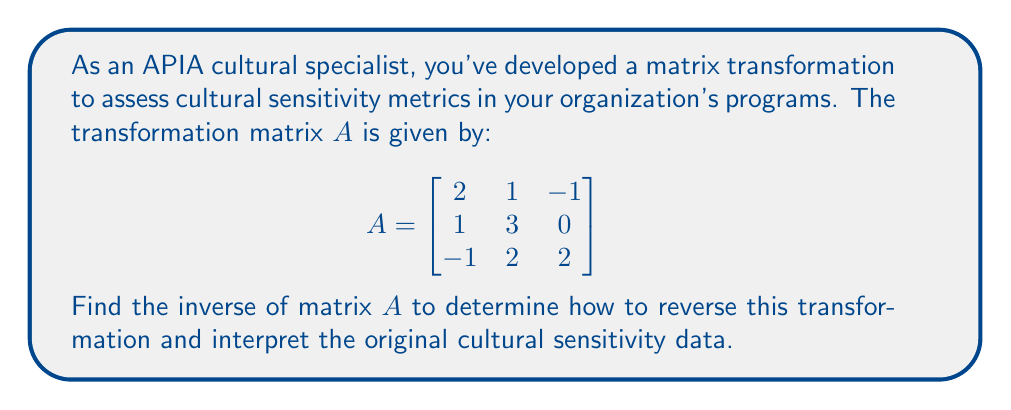Show me your answer to this math problem. To find the inverse of matrix $A$, we'll follow these steps:

1) First, calculate the determinant of $A$ to ensure it's invertible:
   $$\det(A) = 2(3\cdot2 - 0\cdot2) - 1(1\cdot2 - (-1)\cdot2) + (-1)(1\cdot0 - 3\cdot(-1)) = 12 - 6 + 3 = 9$$
   Since $\det(A) \neq 0$, $A$ is invertible.

2) Find the matrix of cofactors:
   $$\text{cof}(A) = \begin{bmatrix}
   (3\cdot2 - 0\cdot2) & -(1\cdot2 - (-1)\cdot2) & (1\cdot0 - 3\cdot(-1)) \\
   -(2\cdot2 - (-1)\cdot(-1)) & (2\cdot2 - (-1)\cdot1) & -(2\cdot0 - 1\cdot(-1)) \\
   (2\cdot0 - 1\cdot2) & -(2\cdot(-1) - 1\cdot1) & (2\cdot3 - 1\cdot1)
   \end{bmatrix}$$

   $$= \begin{bmatrix}
   6 & -4 & 3 \\
   -3 & 5 & 1 \\
   -2 & 3 & 5
   \end{bmatrix}$$

3) Find the adjugate matrix by transposing the cofactor matrix:
   $$\text{adj}(A) = \begin{bmatrix}
   6 & -3 & -2 \\
   -4 & 5 & 3 \\
   3 & 1 & 5
   \end{bmatrix}$$

4) Calculate the inverse using the formula $A^{-1} = \frac{1}{\det(A)}\text{adj}(A)$:
   $$A^{-1} = \frac{1}{9}\begin{bmatrix}
   6 & -3 & -2 \\
   -4 & 5 & 3 \\
   3 & 1 & 5
   \end{bmatrix}$$

5) Simplify the fractions:
   $$A^{-1} = \begin{bmatrix}
   2/3 & -1/3 & -2/9 \\
   -4/9 & 5/9 & 1/3 \\
   1/3 & 1/9 & 5/9
   \end{bmatrix}$$
Answer: $$A^{-1} = \begin{bmatrix}
2/3 & -1/3 & -2/9 \\
-4/9 & 5/9 & 1/3 \\
1/3 & 1/9 & 5/9
\end{bmatrix}$$ 